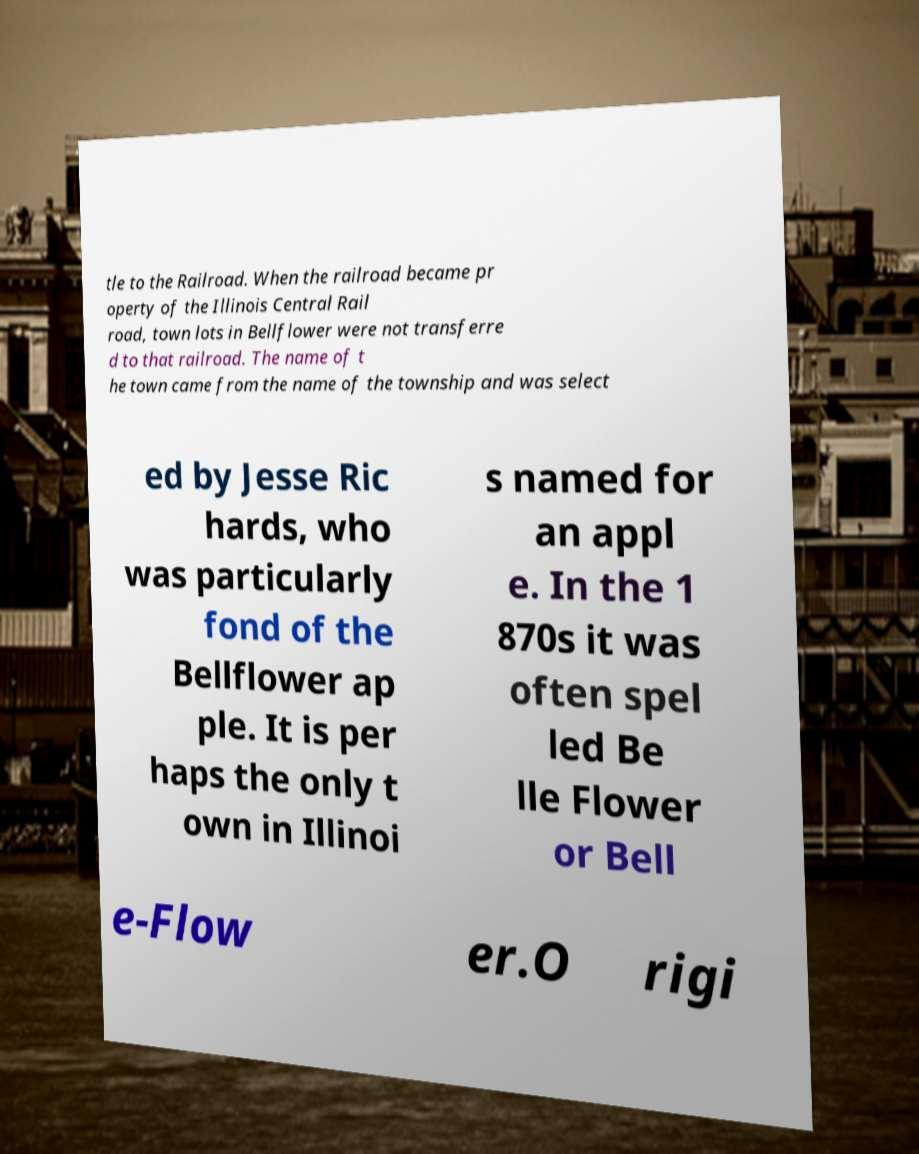Please identify and transcribe the text found in this image. tle to the Railroad. When the railroad became pr operty of the Illinois Central Rail road, town lots in Bellflower were not transferre d to that railroad. The name of t he town came from the name of the township and was select ed by Jesse Ric hards, who was particularly fond of the Bellflower ap ple. It is per haps the only t own in Illinoi s named for an appl e. In the 1 870s it was often spel led Be lle Flower or Bell e-Flow er.O rigi 